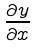<formula> <loc_0><loc_0><loc_500><loc_500>\frac { \partial y } { \partial x }</formula> 